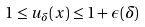<formula> <loc_0><loc_0><loc_500><loc_500>1 \leq u _ { \delta } ( x ) \leq 1 + \epsilon ( \delta )</formula> 